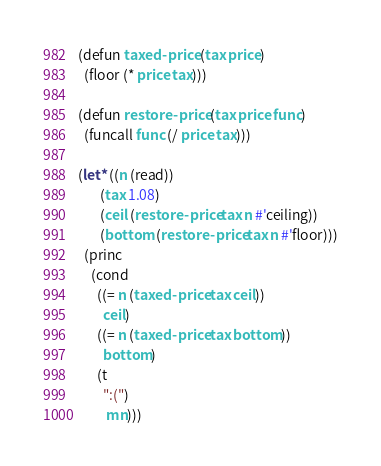Convert code to text. <code><loc_0><loc_0><loc_500><loc_500><_Lisp_>(defun taxed-price (tax price)
  (floor (* price tax)))

(defun restore-price (tax price func)
  (funcall func (/ price tax)))

(let* ((n (read))
       (tax 1.08)
       (ceil (restore-price tax n #'ceiling))
       (bottom (restore-price tax n #'floor)))
  (princ
    (cond 
      ((= n (taxed-price tax ceil))
        ceil)
      ((= n (taxed-price tax bottom))
        bottom)
      (t
        ":(") 
         mn)))</code> 